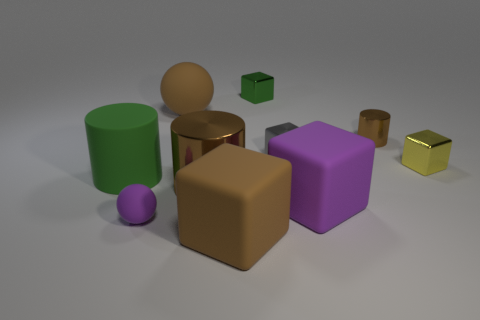Subtract all tiny yellow shiny cubes. How many cubes are left? 4 Subtract all yellow cubes. How many cubes are left? 4 Subtract all cyan cubes. Subtract all blue balls. How many cubes are left? 5 Subtract all balls. How many objects are left? 8 Subtract 1 brown cubes. How many objects are left? 9 Subtract all small shiny objects. Subtract all large green matte objects. How many objects are left? 5 Add 1 matte blocks. How many matte blocks are left? 3 Add 1 big red rubber cylinders. How many big red rubber cylinders exist? 1 